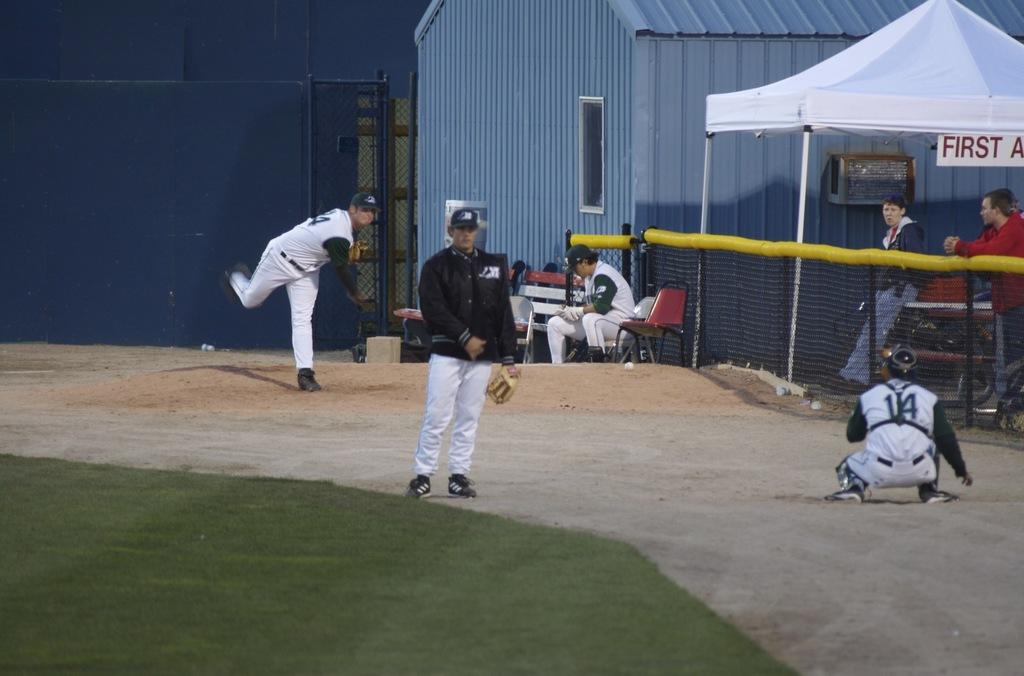<image>
Offer a succinct explanation of the picture presented. The white tent on the side of the picture is for first aid. 